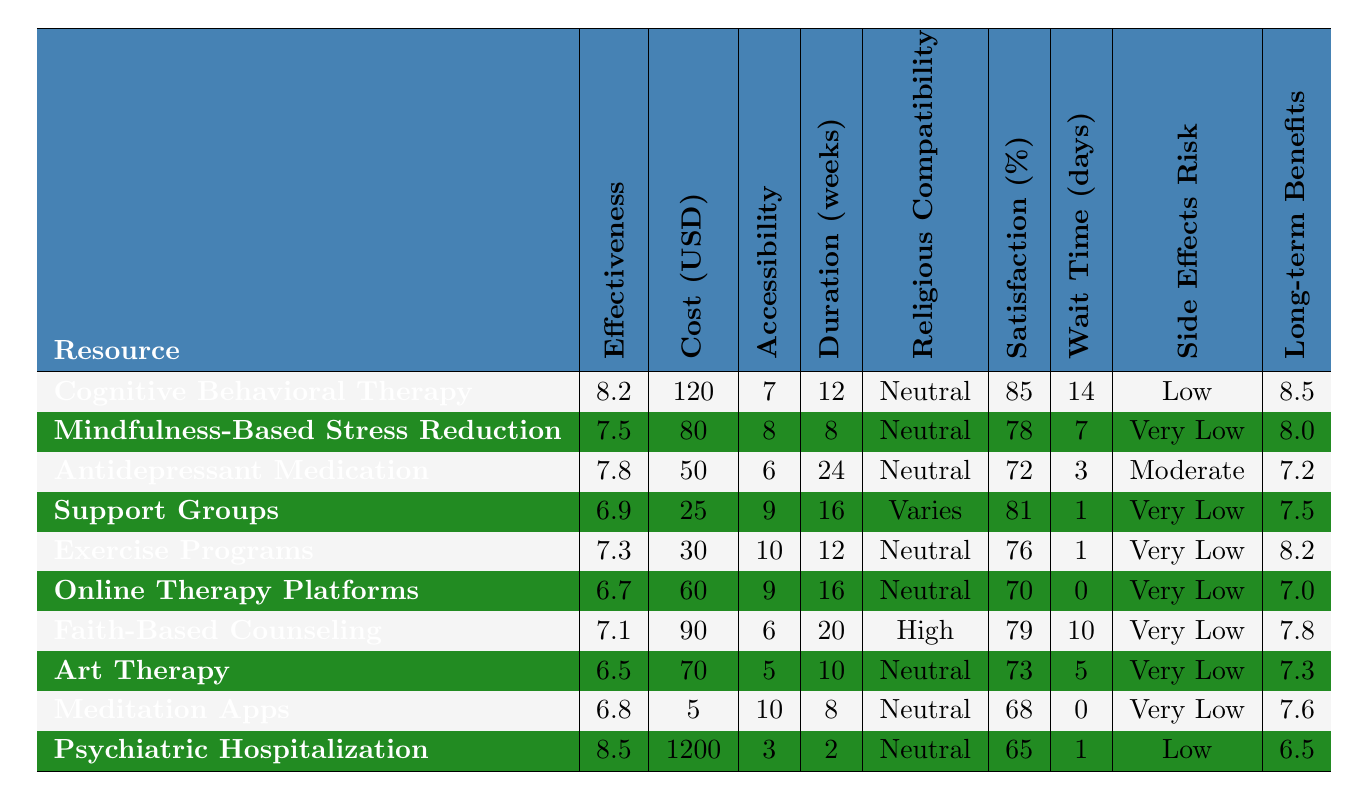What is the effectiveness rating of Support Groups? The table lists the effectiveness rating for Support Groups directly in the relevant column, which is 6.9.
Answer: 6.9 Which mental health resource has the highest patient satisfaction percentage? By comparing all the patient satisfaction percentages in the table, Cognitive Behavioral Therapy has the highest at 85%.
Answer: 85% How much does Exercise Programs cost per session? The cost for Exercise Programs is explicitly stated in the table as 30 USD.
Answer: 30 What is the average effectiveness rating of all the resources? To find the average, sum all the effectiveness ratings (8.2 + 7.5 + 7.8 + 6.9 + 7.3 + 6.7 + 7.1 + 6.5 + 6.8 + 8.5 = 78.8) and divide by the number of resources (10), which gives 78.8 / 10 = 7.88.
Answer: 7.88 Which resource has the lowest cost per session? Looking through the cost column, Meditation Apps has the lowest cost at 5 USD.
Answer: 5 Is there a resource with very low side effects risk that also has a high effectiveness rating? The effectiveness ratings for resources with very low side effects risk are Mindfulness-Based Stress Reduction (7.5), Support Groups (6.9), Exercise Programs (7.3), Online Therapy Platforms (6.7), Faith-Based Counseling (7.1), Art Therapy (6.5), and Meditation Apps (6.8). Among these, Mindfulness-Based Stress Reduction has the highest rating of 7.5.
Answer: Yes, Mindfulness-Based Stress Reduction What is the difference between the effectiveness ratings of Psychiatric Hospitalization and Meditation Apps? The effectiveness rating for Psychiatric Hospitalization is 8.5 and for Meditation Apps is 6.8. The difference is 8.5 - 6.8 = 1.7.
Answer: 1.7 Which mental health resource has the longest recommended duration in weeks? The resource with the longest recommended duration is Antidepressant Medication at 24 weeks.
Answer: 24 weeks What is the maximum waiting time among all the resources? By examining the waiting time column, the maximum waiting time is 14 days for Cognitive Behavioral Therapy.
Answer: 14 days Is there more than one resource with a satisfaction percentage above 80%? Cognitive Behavioral Therapy (85%) and Support Groups (81%) both have satisfaction percentages above 80%, indicating there are two such resources.
Answer: Yes 